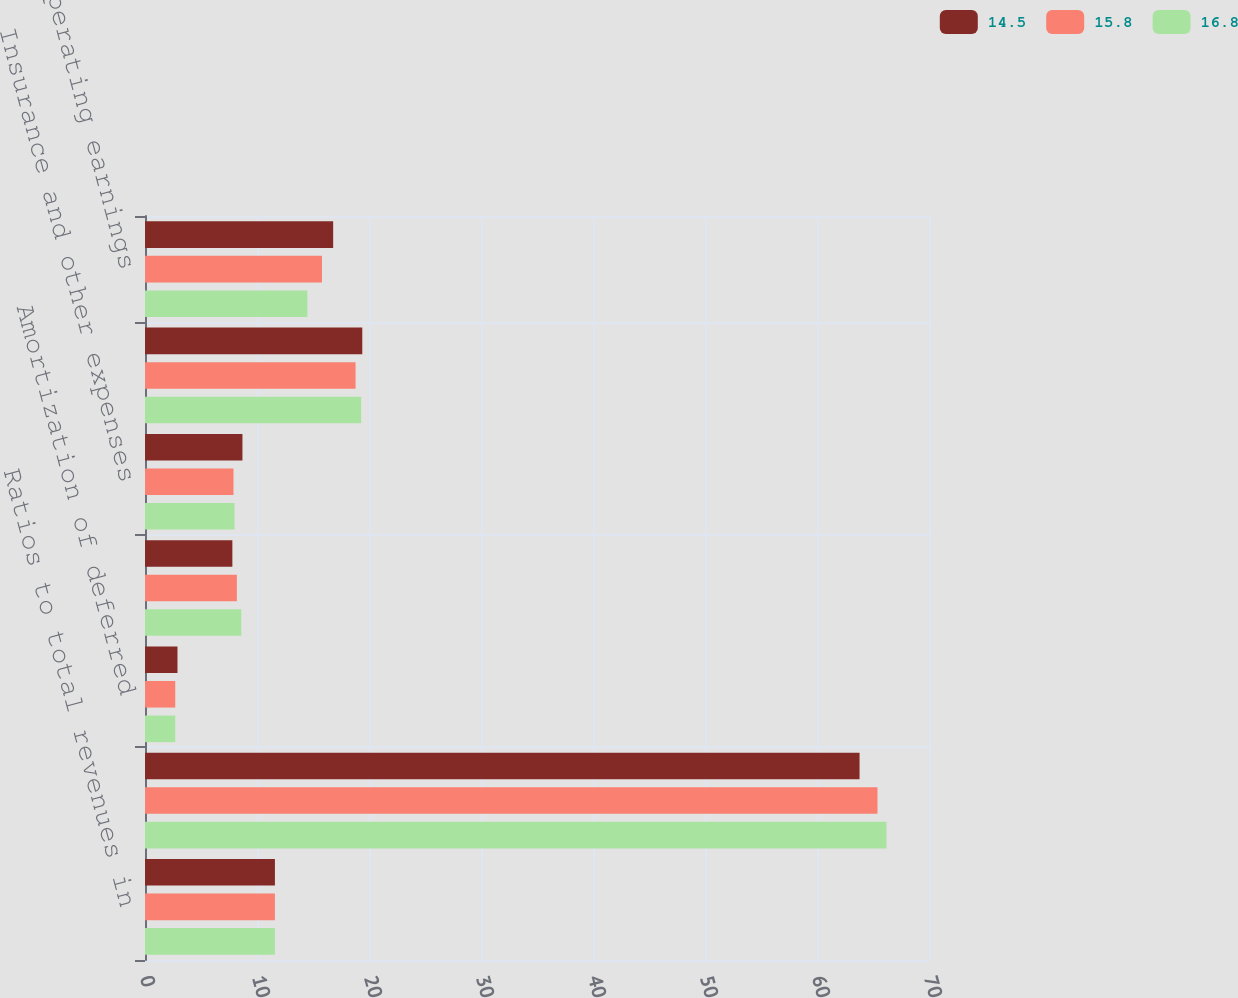Convert chart. <chart><loc_0><loc_0><loc_500><loc_500><stacked_bar_chart><ecel><fcel>Ratios to total revenues in<fcel>Benefits and claims<fcel>Amortization of deferred<fcel>Insurance commissions<fcel>Insurance and other expenses<fcel>Total operating expenses<fcel>Pretax operating earnings<nl><fcel>14.5<fcel>11.6<fcel>63.8<fcel>2.9<fcel>7.8<fcel>8.7<fcel>19.4<fcel>16.8<nl><fcel>15.8<fcel>11.6<fcel>65.4<fcel>2.7<fcel>8.2<fcel>7.9<fcel>18.8<fcel>15.8<nl><fcel>16.8<fcel>11.6<fcel>66.2<fcel>2.7<fcel>8.6<fcel>8<fcel>19.3<fcel>14.5<nl></chart> 